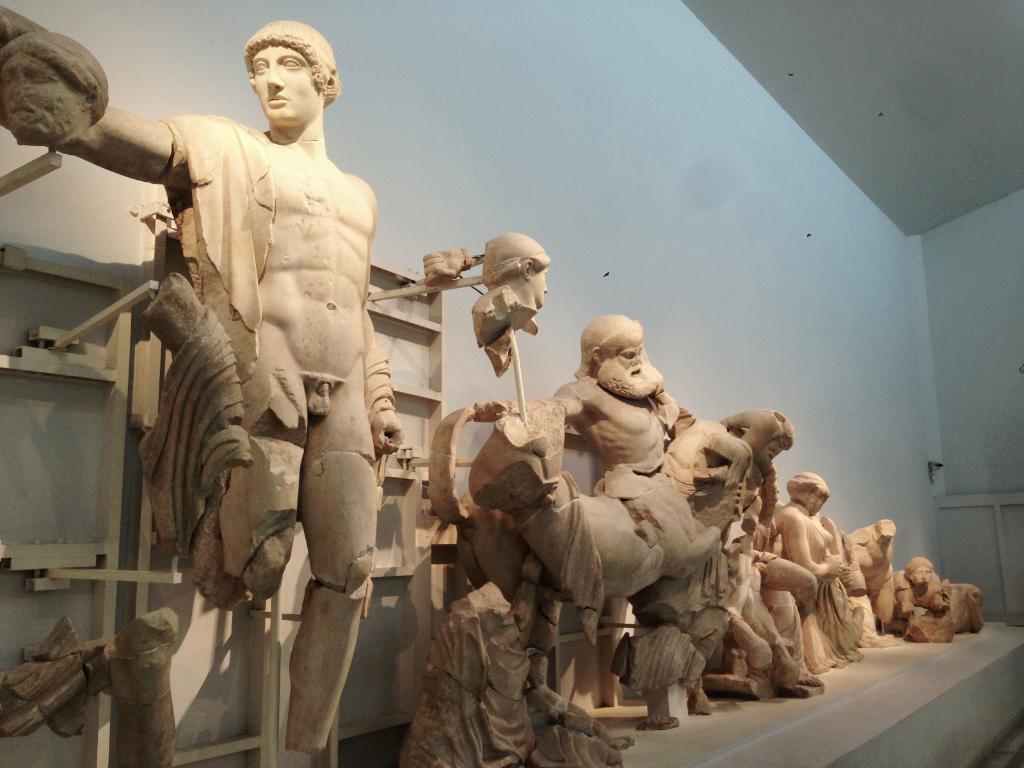Please provide a concise description of this image. Here we can see sculptures. In the background there is a wall. 